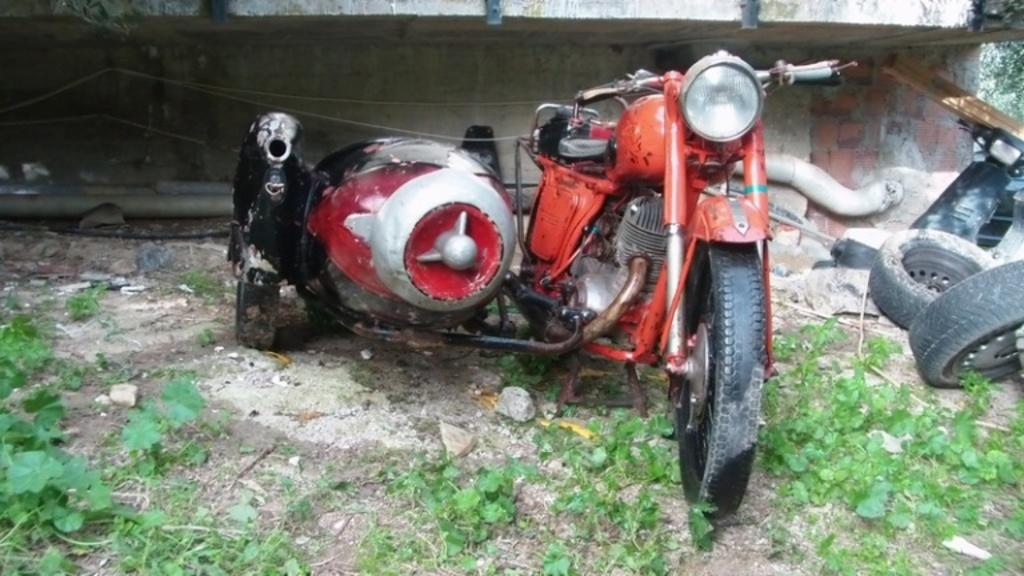What types of objects are in the image? There are vehicles in the image. What feature is common among the vehicles? Wheels are visible in the image. What other objects can be seen in the image? Pipes are present in the image. What type of natural elements are visible in the image? Plants are observable in the image. What type of tail can be seen on the plants in the image? There are no tails visible in the image, as plants do not have tails. 